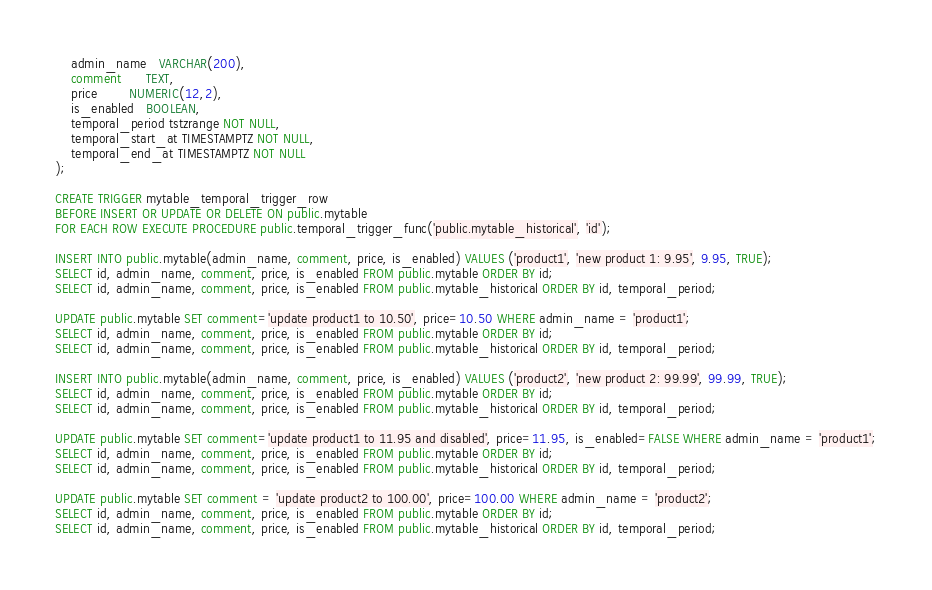<code> <loc_0><loc_0><loc_500><loc_500><_SQL_>    admin_name   VARCHAR(200),
    comment      TEXT,
    price        NUMERIC(12,2),
    is_enabled   BOOLEAN,
    temporal_period tstzrange NOT NULL,
    temporal_start_at TIMESTAMPTZ NOT NULL,
    temporal_end_at TIMESTAMPTZ NOT NULL
);

CREATE TRIGGER mytable_temporal_trigger_row 
BEFORE INSERT OR UPDATE OR DELETE ON public.mytable
FOR EACH ROW EXECUTE PROCEDURE public.temporal_trigger_func('public.mytable_historical', 'id');

INSERT INTO public.mytable(admin_name, comment, price, is_enabled) VALUES ('product1', 'new product 1: 9.95', 9.95, TRUE);
SELECT id, admin_name, comment, price, is_enabled FROM public.mytable ORDER BY id;
SELECT id, admin_name, comment, price, is_enabled FROM public.mytable_historical ORDER BY id, temporal_period;

UPDATE public.mytable SET comment='update product1 to 10.50', price=10.50 WHERE admin_name = 'product1';
SELECT id, admin_name, comment, price, is_enabled FROM public.mytable ORDER BY id;
SELECT id, admin_name, comment, price, is_enabled FROM public.mytable_historical ORDER BY id, temporal_period;

INSERT INTO public.mytable(admin_name, comment, price, is_enabled) VALUES ('product2', 'new product 2: 99.99', 99.99, TRUE);
SELECT id, admin_name, comment, price, is_enabled FROM public.mytable ORDER BY id;
SELECT id, admin_name, comment, price, is_enabled FROM public.mytable_historical ORDER BY id, temporal_period;

UPDATE public.mytable SET comment='update product1 to 11.95 and disabled', price=11.95, is_enabled=FALSE WHERE admin_name = 'product1';
SELECT id, admin_name, comment, price, is_enabled FROM public.mytable ORDER BY id;
SELECT id, admin_name, comment, price, is_enabled FROM public.mytable_historical ORDER BY id, temporal_period;

UPDATE public.mytable SET comment = 'update product2 to 100.00', price=100.00 WHERE admin_name = 'product2';
SELECT id, admin_name, comment, price, is_enabled FROM public.mytable ORDER BY id;
SELECT id, admin_name, comment, price, is_enabled FROM public.mytable_historical ORDER BY id, temporal_period;
</code> 